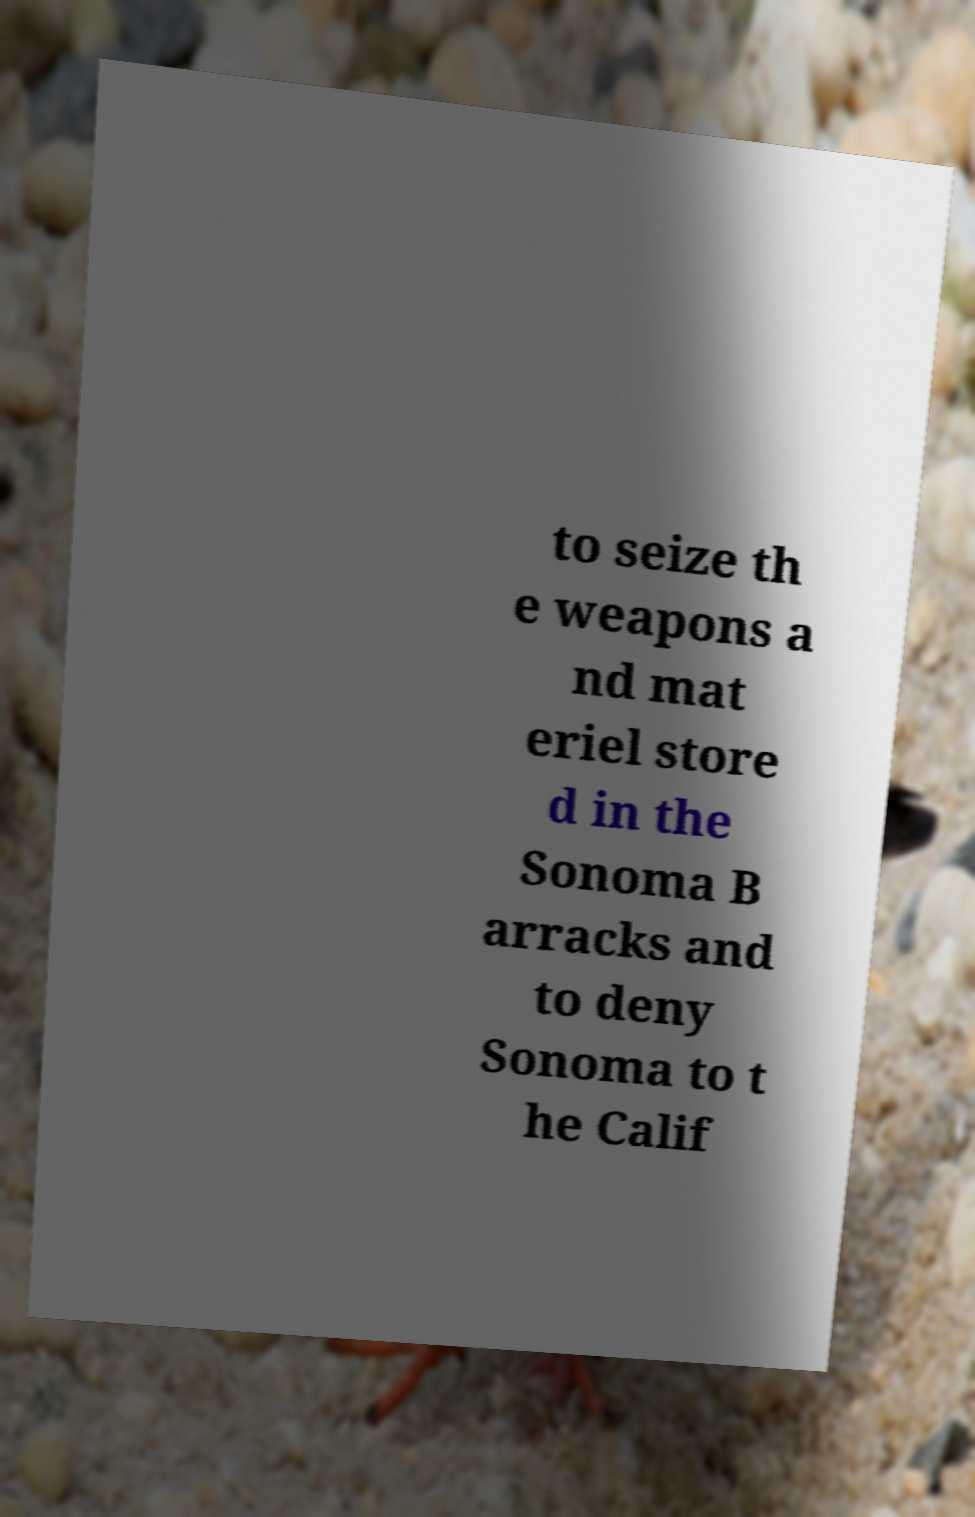For documentation purposes, I need the text within this image transcribed. Could you provide that? to seize th e weapons a nd mat eriel store d in the Sonoma B arracks and to deny Sonoma to t he Calif 